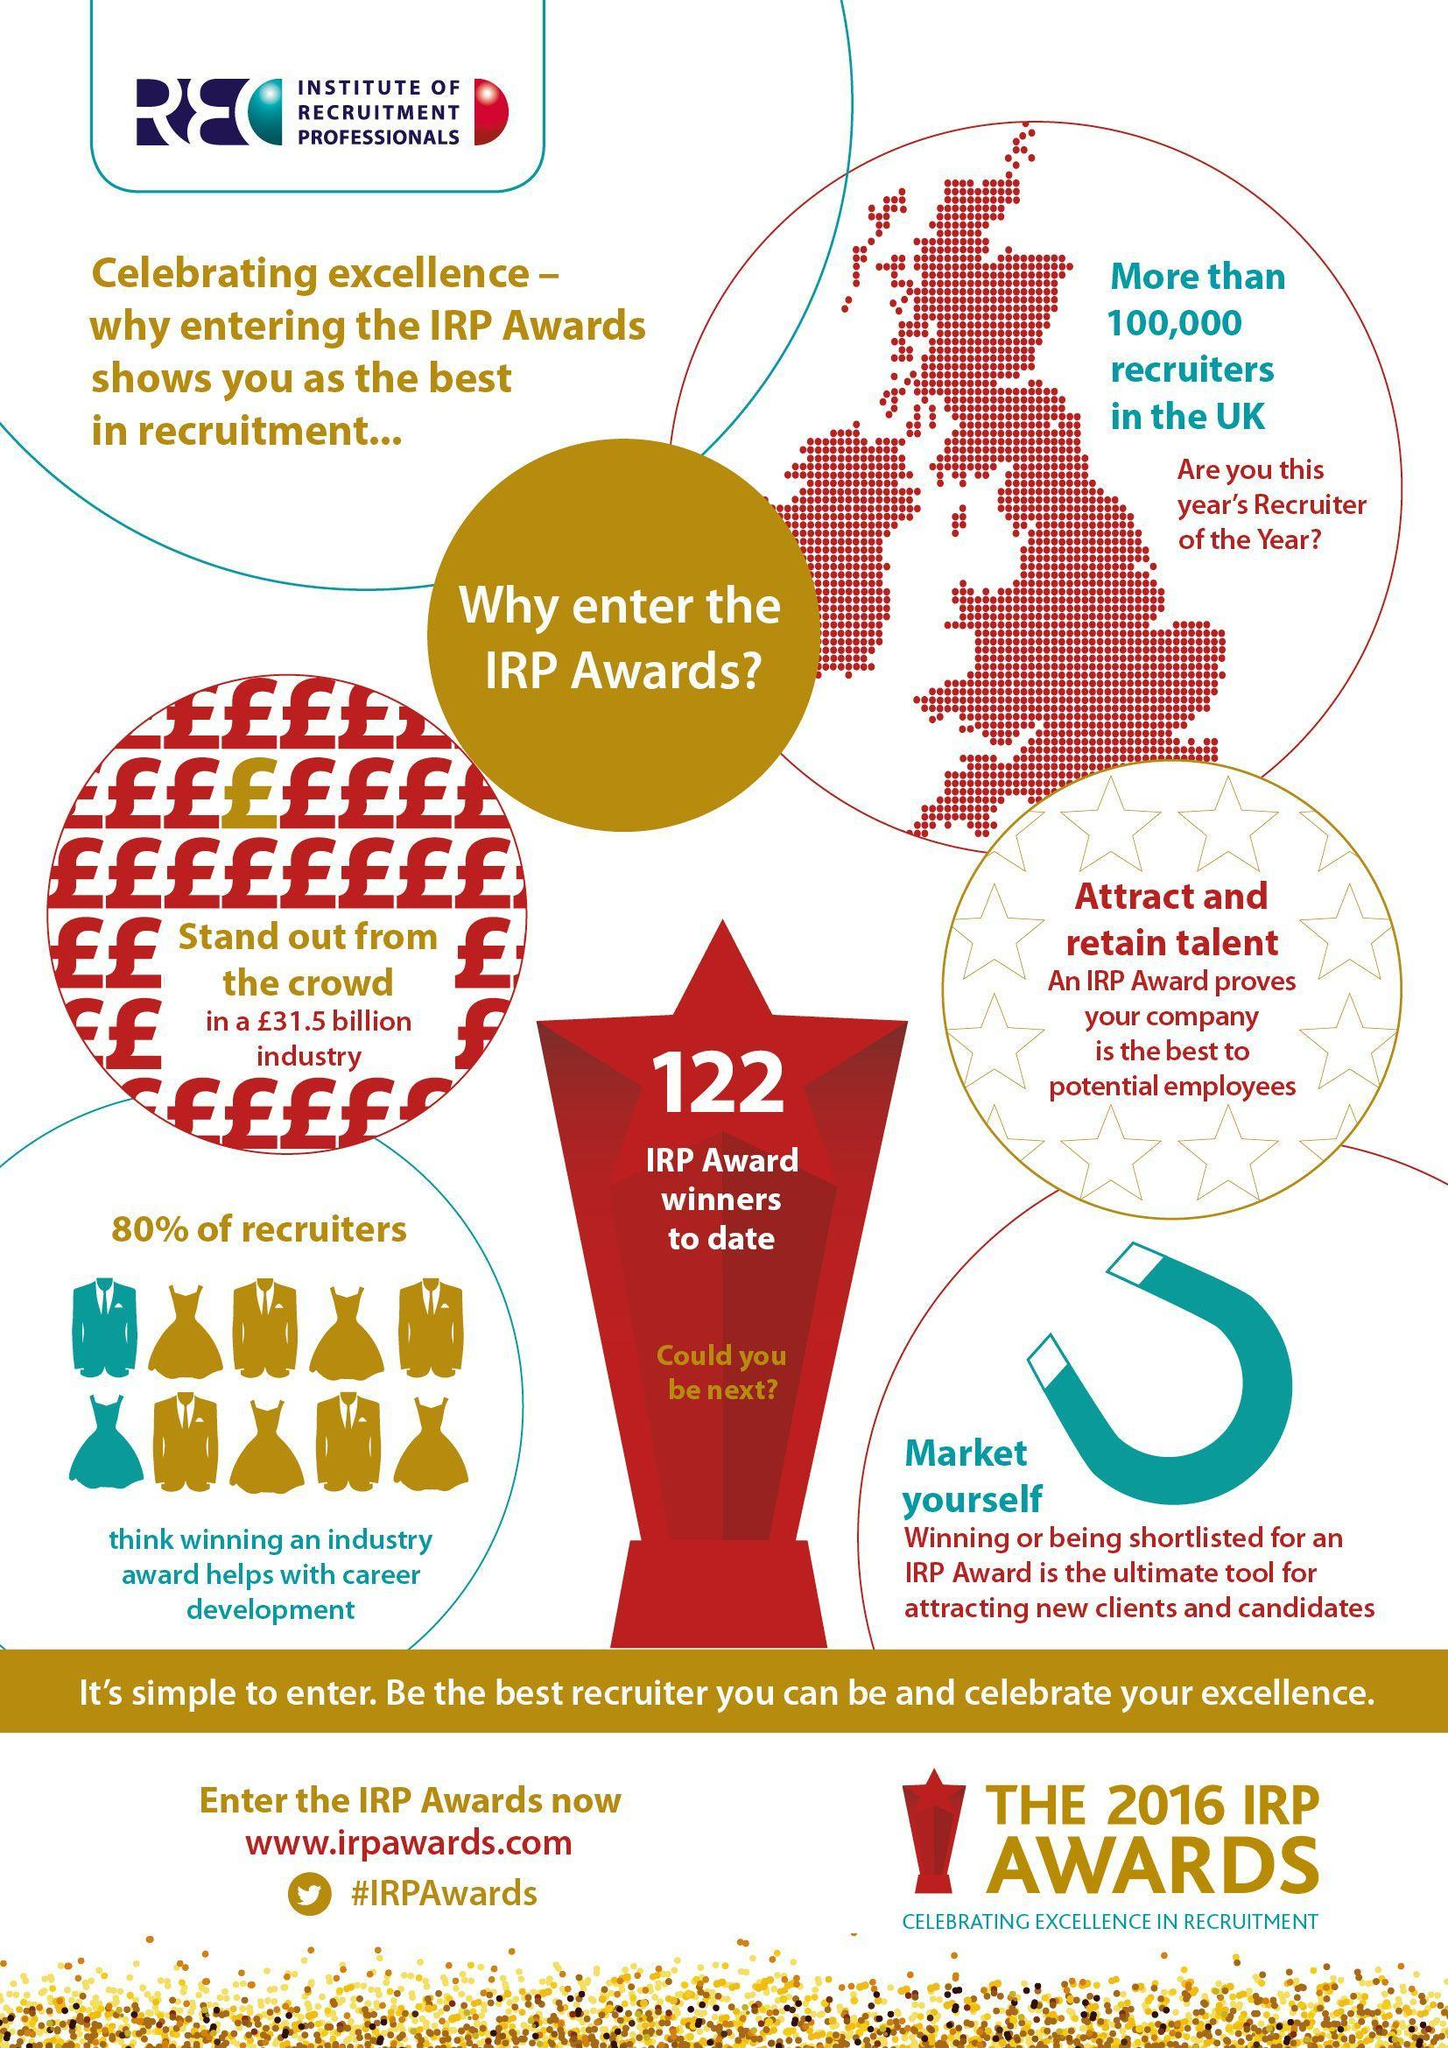What is the number written on the trophy?
Answer the question with a short phrase. 122 What percentage of recruiters do not believe that winning an industry award helps with career development? 20% 